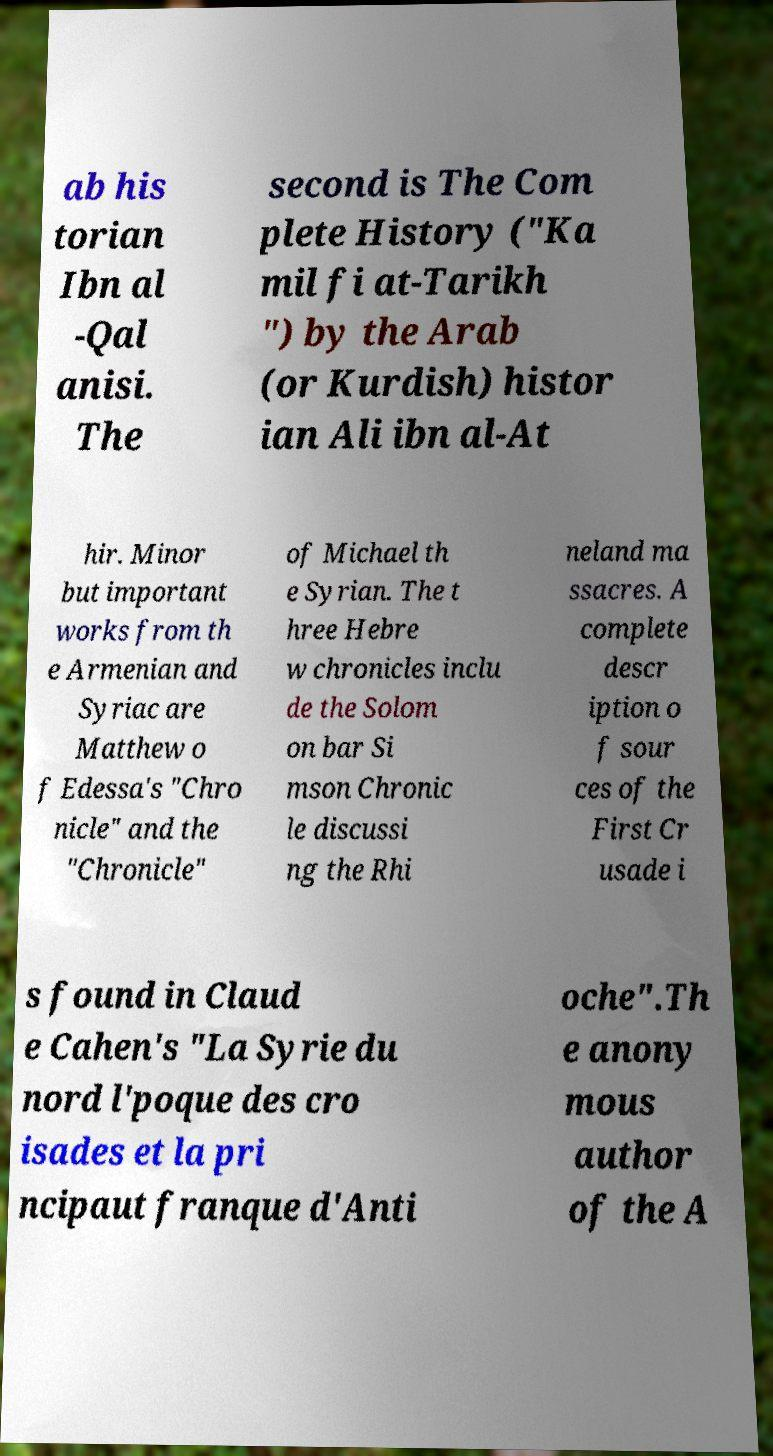For documentation purposes, I need the text within this image transcribed. Could you provide that? ab his torian Ibn al -Qal anisi. The second is The Com plete History ("Ka mil fi at-Tarikh ") by the Arab (or Kurdish) histor ian Ali ibn al-At hir. Minor but important works from th e Armenian and Syriac are Matthew o f Edessa's "Chro nicle" and the "Chronicle" of Michael th e Syrian. The t hree Hebre w chronicles inclu de the Solom on bar Si mson Chronic le discussi ng the Rhi neland ma ssacres. A complete descr iption o f sour ces of the First Cr usade i s found in Claud e Cahen's "La Syrie du nord l'poque des cro isades et la pri ncipaut franque d'Anti oche".Th e anony mous author of the A 